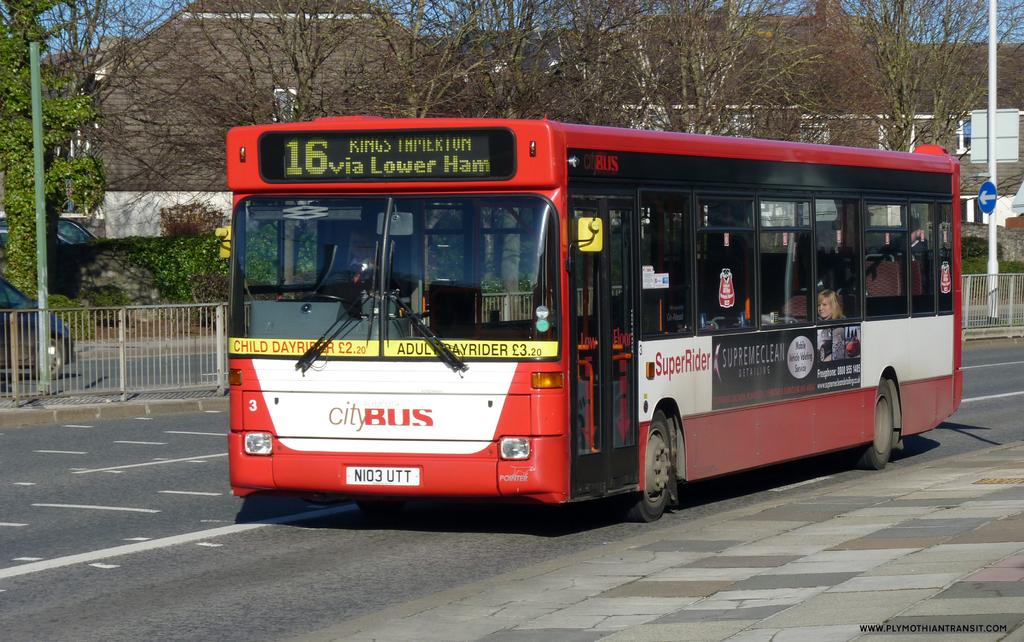What is the main subject in the center of the image? There is a red color bus in the center of the image. What is located behind the bus? There is a boundary behind the bus. What can be seen in the background of the image? There are houses, poles, and trees in the background of the image. What type of cherry is being used as a decoration on the bus in the image? There is no cherry present in the image, and therefore no such decoration can be observed. What hobbies do the people living in the houses in the background of the image have? We cannot determine the hobbies of the people living in the houses in the background of the image from the information provided. 